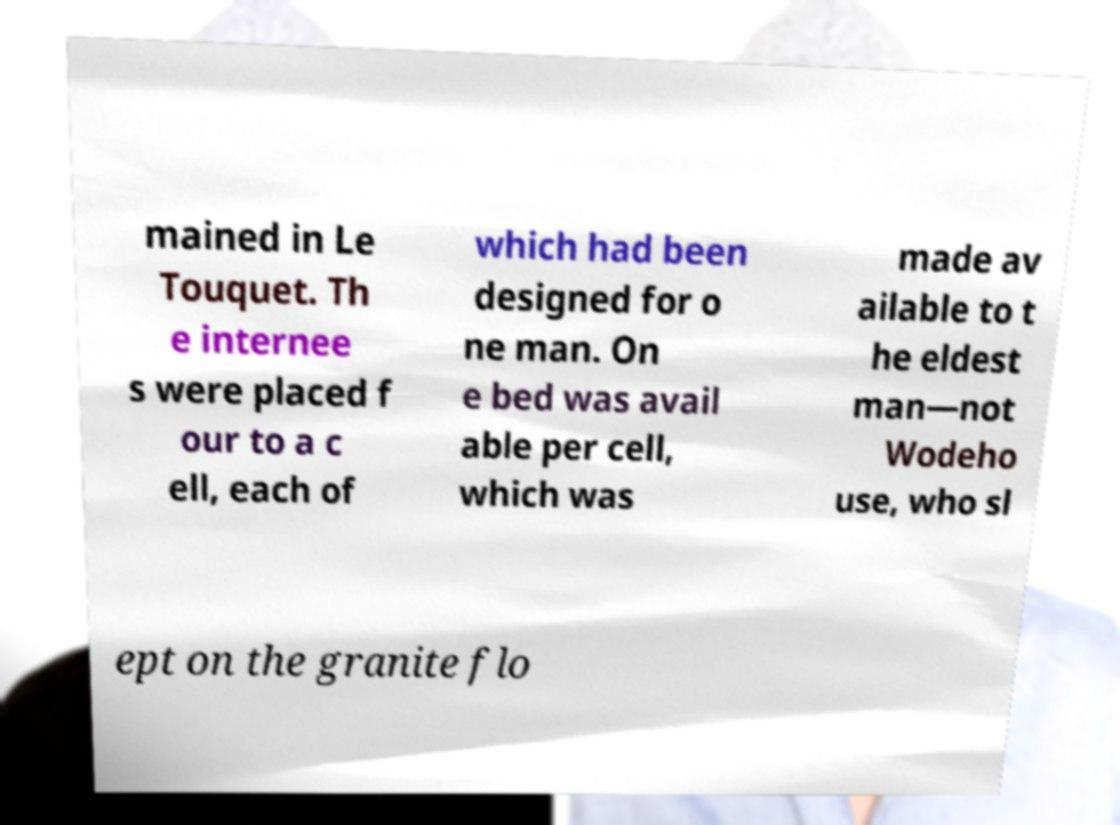Can you accurately transcribe the text from the provided image for me? mained in Le Touquet. Th e internee s were placed f our to a c ell, each of which had been designed for o ne man. On e bed was avail able per cell, which was made av ailable to t he eldest man—not Wodeho use, who sl ept on the granite flo 